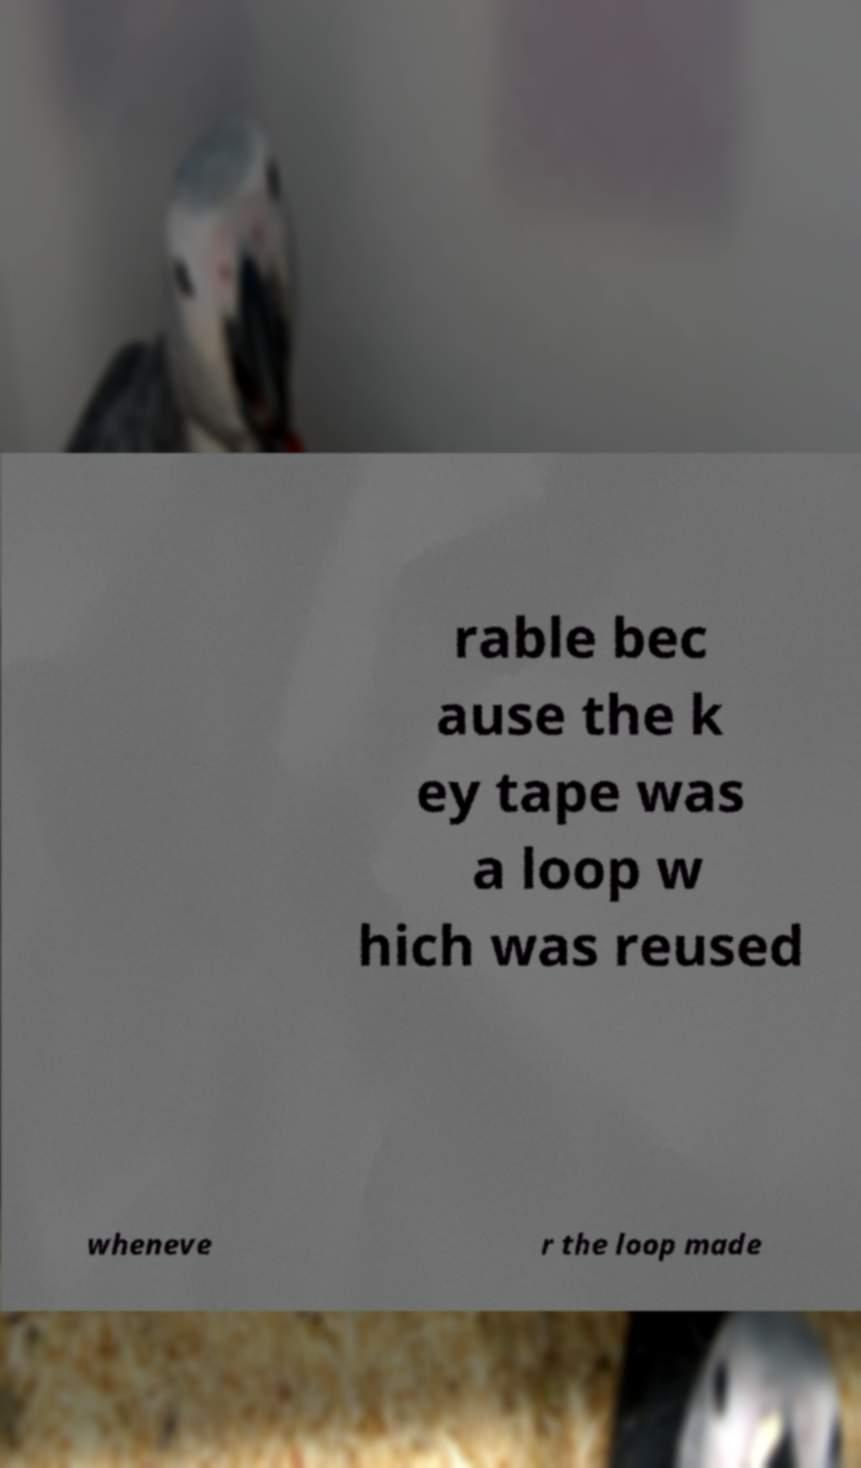Could you assist in decoding the text presented in this image and type it out clearly? rable bec ause the k ey tape was a loop w hich was reused wheneve r the loop made 